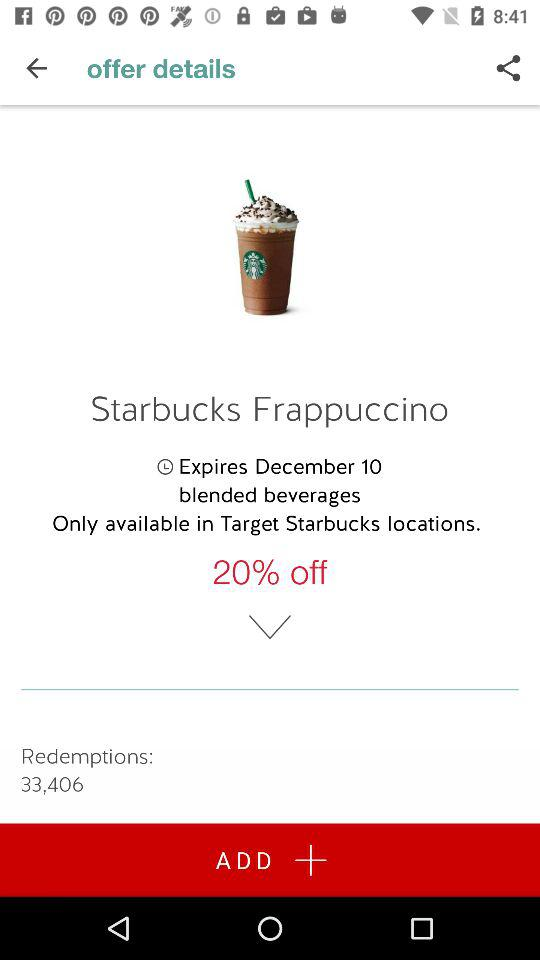On what product is there a 20% discount? The product name is "Starbucks Frappuccino". 